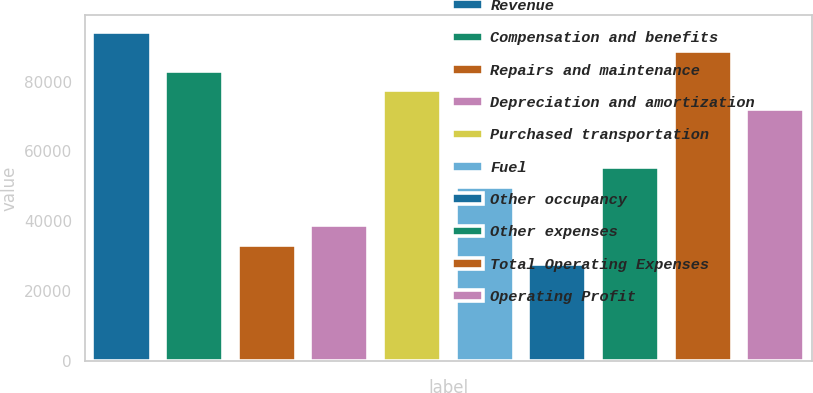<chart> <loc_0><loc_0><loc_500><loc_500><bar_chart><fcel>Revenue<fcel>Compensation and benefits<fcel>Repairs and maintenance<fcel>Depreciation and amortization<fcel>Purchased transportation<fcel>Fuel<fcel>Other occupancy<fcel>Other expenses<fcel>Total Operating Expenses<fcel>Operating Profit<nl><fcel>94241.4<fcel>83154.7<fcel>33264.7<fcel>38808<fcel>77611.4<fcel>49894.7<fcel>27721.3<fcel>55438<fcel>88698.1<fcel>72068<nl></chart> 